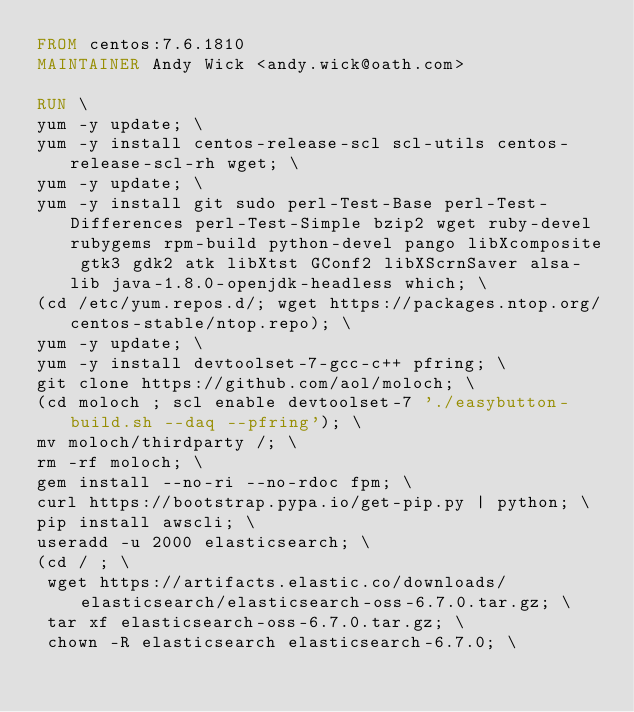Convert code to text. <code><loc_0><loc_0><loc_500><loc_500><_Dockerfile_>FROM centos:7.6.1810
MAINTAINER Andy Wick <andy.wick@oath.com>

RUN \
yum -y update; \
yum -y install centos-release-scl scl-utils centos-release-scl-rh wget; \
yum -y update; \
yum -y install git sudo perl-Test-Base perl-Test-Differences perl-Test-Simple bzip2 wget ruby-devel rubygems rpm-build python-devel pango libXcomposite gtk3 gdk2 atk libXtst GConf2 libXScrnSaver alsa-lib java-1.8.0-openjdk-headless which; \
(cd /etc/yum.repos.d/; wget https://packages.ntop.org/centos-stable/ntop.repo); \
yum -y update; \
yum -y install devtoolset-7-gcc-c++ pfring; \
git clone https://github.com/aol/moloch; \
(cd moloch ; scl enable devtoolset-7 './easybutton-build.sh --daq --pfring'); \
mv moloch/thirdparty /; \
rm -rf moloch; \
gem install --no-ri --no-rdoc fpm; \
curl https://bootstrap.pypa.io/get-pip.py | python; \
pip install awscli; \
useradd -u 2000 elasticsearch; \
(cd / ; \
 wget https://artifacts.elastic.co/downloads/elasticsearch/elasticsearch-oss-6.7.0.tar.gz; \
 tar xf elasticsearch-oss-6.7.0.tar.gz; \
 chown -R elasticsearch elasticsearch-6.7.0; \</code> 